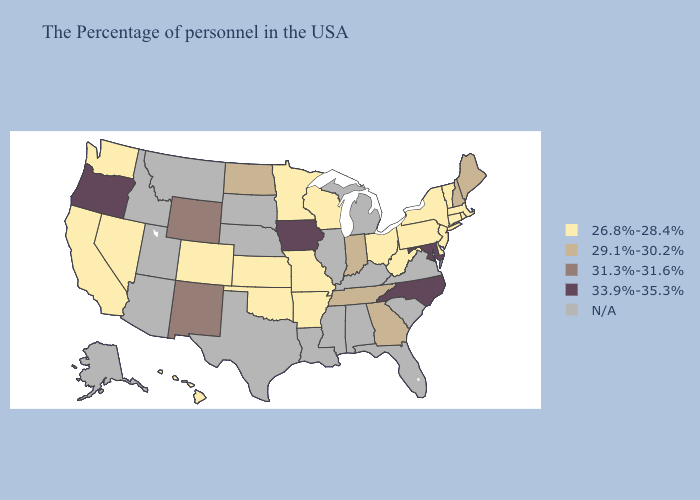Name the states that have a value in the range 33.9%-35.3%?
Be succinct. Maryland, North Carolina, Iowa, Oregon. Which states have the highest value in the USA?
Quick response, please. Maryland, North Carolina, Iowa, Oregon. Does Oklahoma have the lowest value in the USA?
Keep it brief. Yes. Name the states that have a value in the range N/A?
Be succinct. Virginia, South Carolina, Florida, Michigan, Kentucky, Alabama, Illinois, Mississippi, Louisiana, Nebraska, Texas, South Dakota, Utah, Montana, Arizona, Idaho, Alaska. Does the first symbol in the legend represent the smallest category?
Give a very brief answer. Yes. What is the highest value in the MidWest ?
Concise answer only. 33.9%-35.3%. Name the states that have a value in the range N/A?
Short answer required. Virginia, South Carolina, Florida, Michigan, Kentucky, Alabama, Illinois, Mississippi, Louisiana, Nebraska, Texas, South Dakota, Utah, Montana, Arizona, Idaho, Alaska. What is the lowest value in states that border Kansas?
Answer briefly. 26.8%-28.4%. Name the states that have a value in the range N/A?
Quick response, please. Virginia, South Carolina, Florida, Michigan, Kentucky, Alabama, Illinois, Mississippi, Louisiana, Nebraska, Texas, South Dakota, Utah, Montana, Arizona, Idaho, Alaska. Name the states that have a value in the range 29.1%-30.2%?
Concise answer only. Maine, New Hampshire, Georgia, Indiana, Tennessee, North Dakota. Among the states that border Idaho , which have the highest value?
Be succinct. Oregon. What is the value of Nebraska?
Give a very brief answer. N/A. Name the states that have a value in the range N/A?
Keep it brief. Virginia, South Carolina, Florida, Michigan, Kentucky, Alabama, Illinois, Mississippi, Louisiana, Nebraska, Texas, South Dakota, Utah, Montana, Arizona, Idaho, Alaska. 